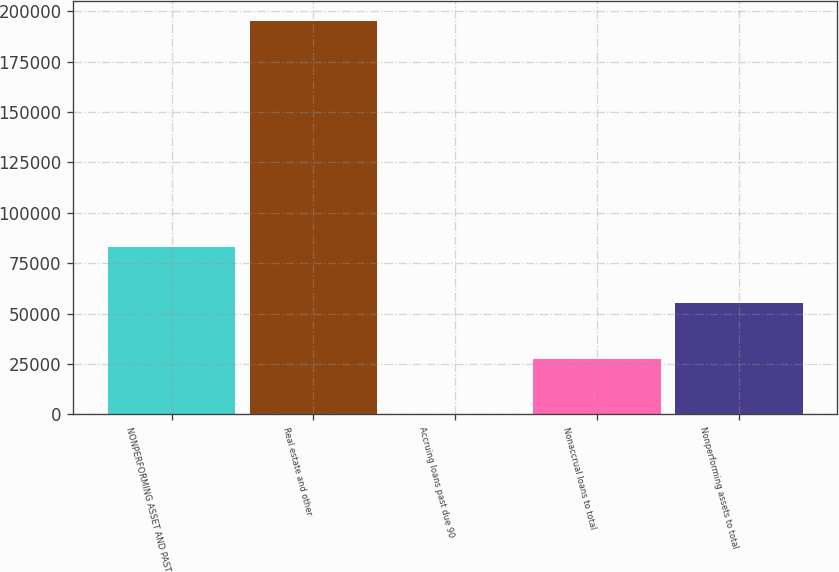Convert chart to OTSL. <chart><loc_0><loc_0><loc_500><loc_500><bar_chart><fcel>NONPERFORMING ASSET AND PAST<fcel>Real estate and other<fcel>Accruing loans past due 90<fcel>Nonaccrual loans to total<fcel>Nonperforming assets to total<nl><fcel>82885.7<fcel>195085<fcel>0.36<fcel>27628.8<fcel>55257.3<nl></chart> 